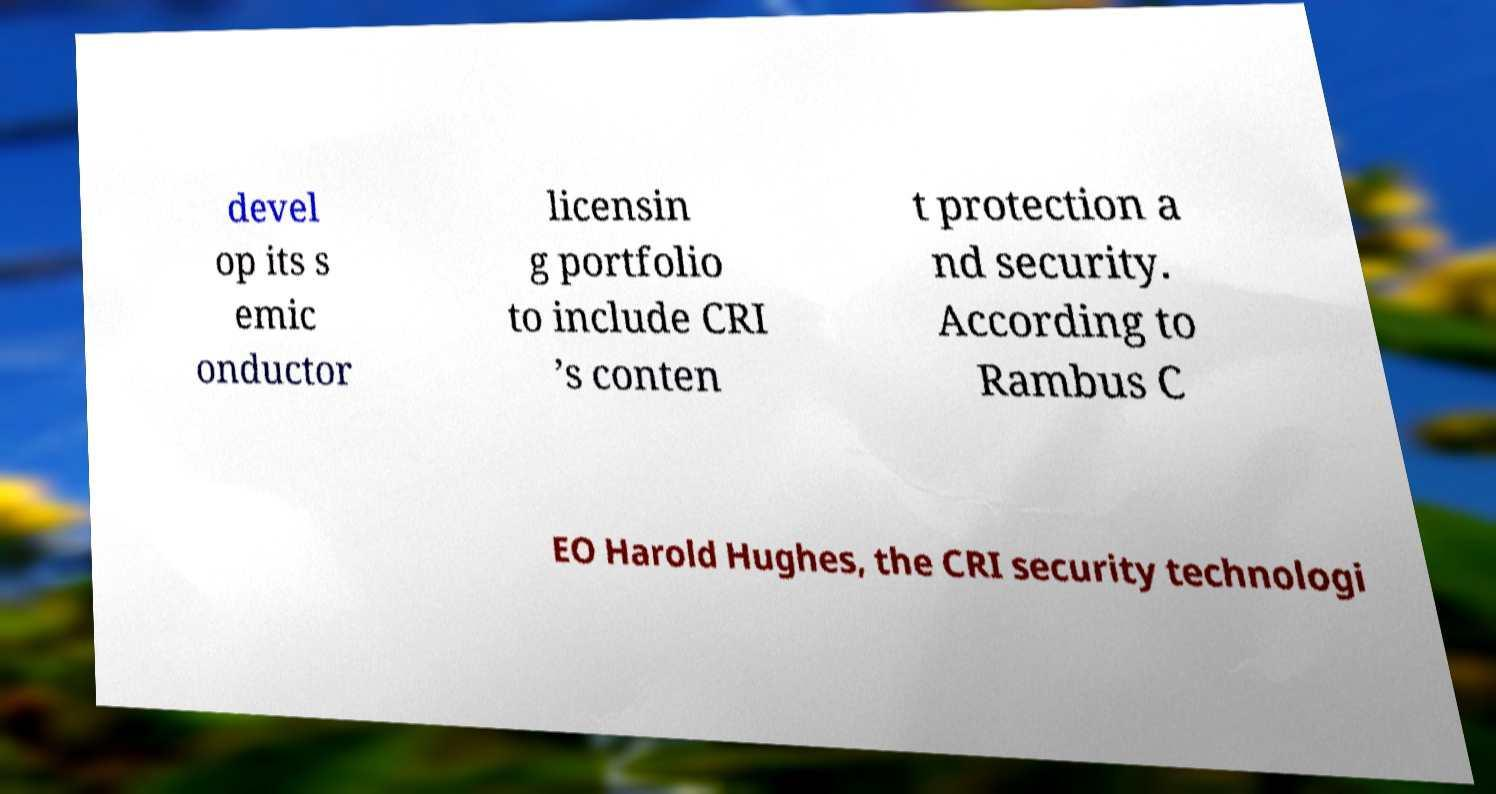I need the written content from this picture converted into text. Can you do that? devel op its s emic onductor licensin g portfolio to include CRI ’s conten t protection a nd security. According to Rambus C EO Harold Hughes, the CRI security technologi 